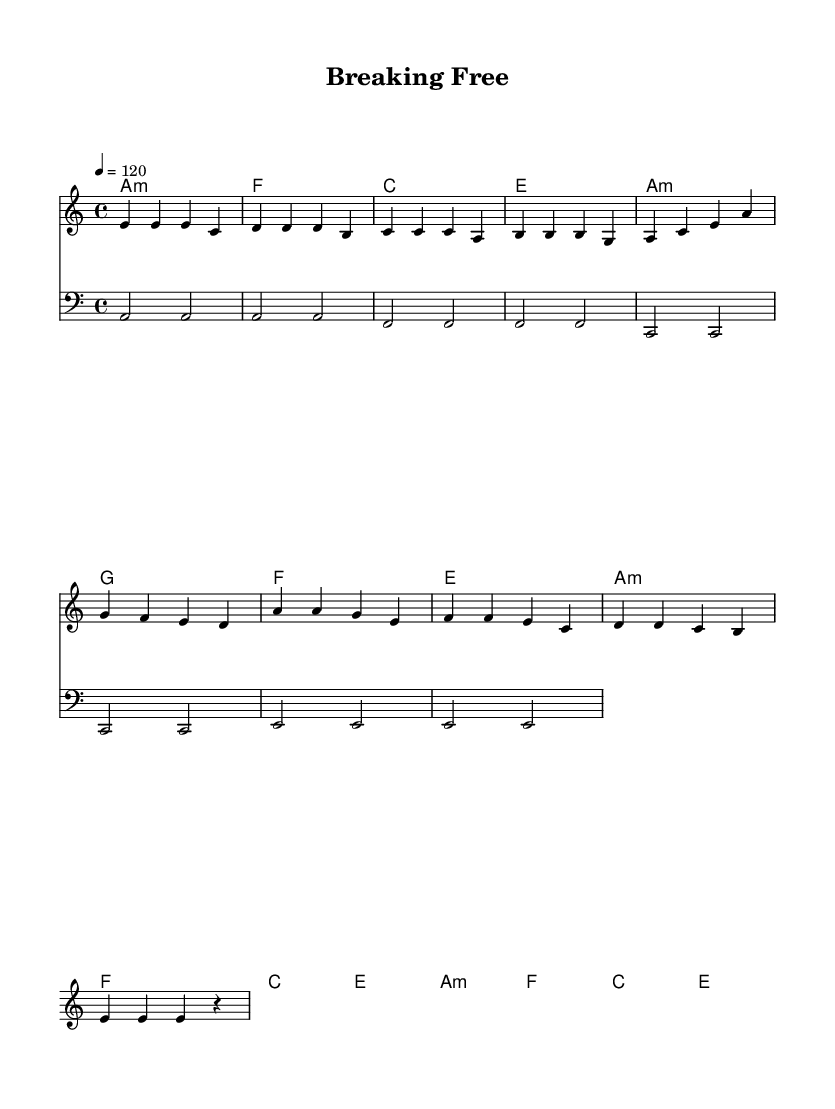What is the key signature of this music? The key signature indicates the tonic and scale of the piece. Here, it shows an A minor key signature, which has no sharps or flats indicated in the score.
Answer: A minor What is the time signature of this music? The time signature is located at the beginning of the score, showing that it is in 4/4 time, meaning there are four beats in each measure.
Answer: 4/4 What is the tempo marking for this piece? The tempo marking shows the speed of the music; in this score, it indicates a tempo of 120 beats per minute, which is marked above the staff.
Answer: 120 How many sections are there in the song structure? By analyzing the flow of the melody and lyrics, we can see that there are three distinct sections: verse, pre-chorus, and chorus, each with its specific set of musical phrases.
Answer: Three What type of musical progression is used in the verse? Looking at the chord mode indicated under the verse section, we notice that it follows a minor chord progression: A minor, F, C, and E, which contributes to its emotional tone.
Answer: Minor What does the chorus suggest about the song's theme? The chorus lyrics emphasize breaking free and liberation from constraints, reflecting themes of personal freedom and hope, aligning with the disco theme of celebration and escape.
Answer: Freedom What is the main instrument indicated for the melody? The score lists a staff labeled "melody," which is typically played by instruments like the piano or synthesizer in disco music, and it's the primary instrument performing the melody lines.
Answer: Melody 